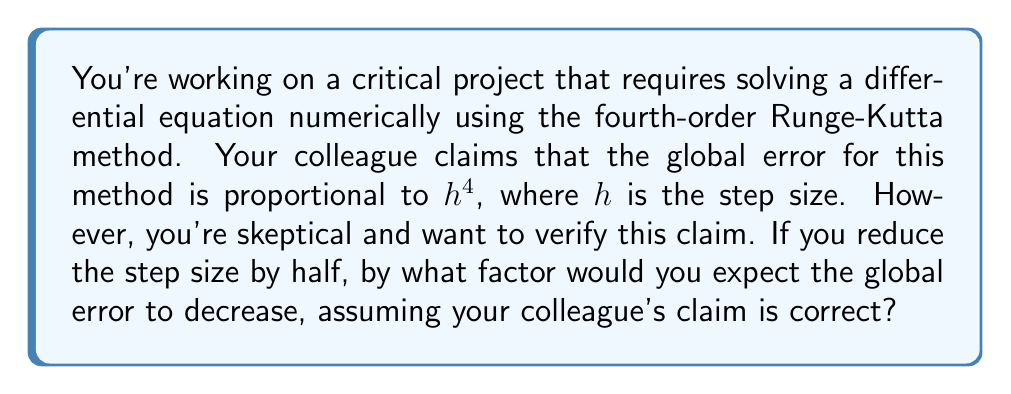Help me with this question. Let's approach this step-by-step:

1) The claim is that the global error $E$ is proportional to $h^4$, where $h$ is the step size. We can express this mathematically as:

   $E \propto h^4$

2) This means we can write the error as:

   $E = Ch^4$

   where $C$ is some constant.

3) Now, let's consider what happens when we halve the step size. The new step size will be $h/2$, and the new error $E_{new}$ will be:

   $E_{new} = C(h/2)^4$

4) Let's expand this:

   $E_{new} = C(h^4/16)$

5) Now, let's find the ratio of the new error to the original error:

   $\frac{E_{new}}{E} = \frac{C(h^4/16)}{Ch^4} = \frac{1}{16}$

6) This means that when we halve the step size, the error becomes $1/16$ of what it was originally.

7) In other words, the error decreases by a factor of 16.

This verification supports your colleague's claim about the order of the global error for the fourth-order Runge-Kutta method.
Answer: The global error would be expected to decrease by a factor of 16. 